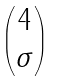<formula> <loc_0><loc_0><loc_500><loc_500>\begin{pmatrix} 4 \\ \sigma \end{pmatrix}</formula> 